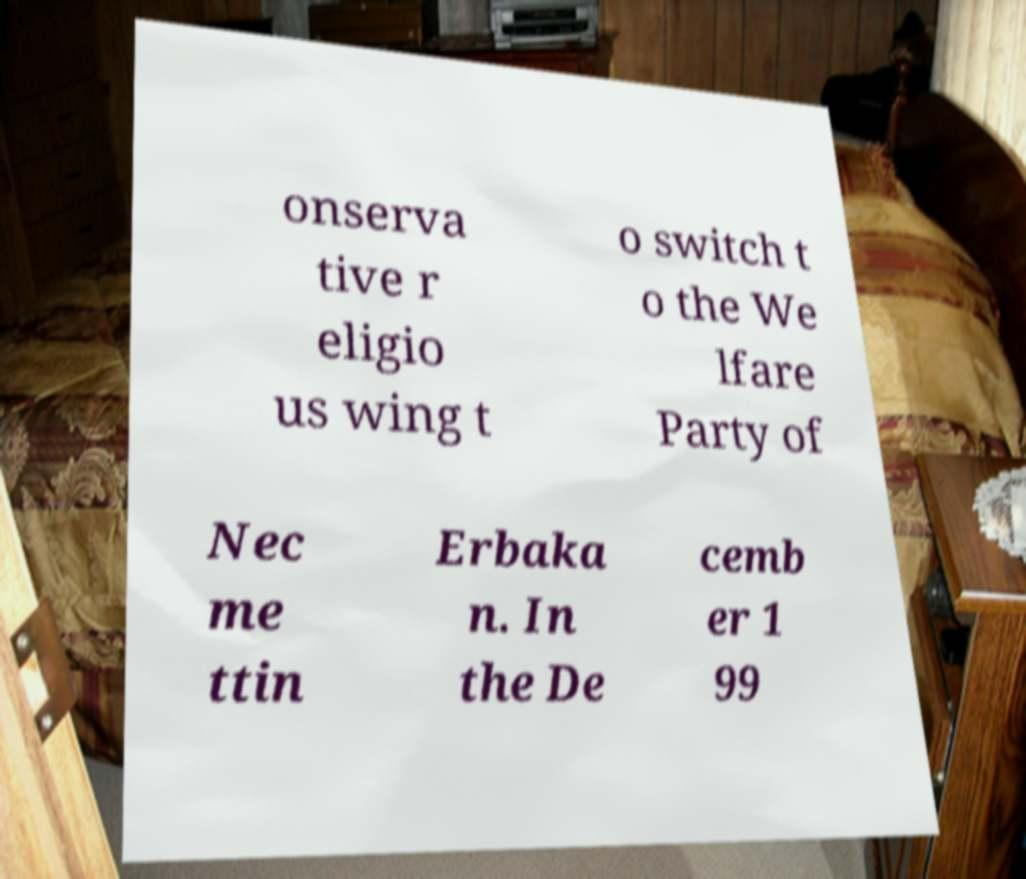Please identify and transcribe the text found in this image. onserva tive r eligio us wing t o switch t o the We lfare Party of Nec me ttin Erbaka n. In the De cemb er 1 99 